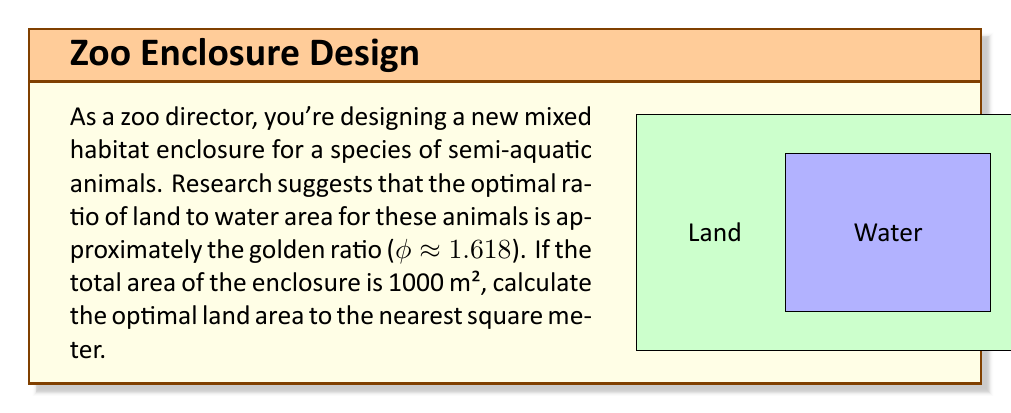Can you solve this math problem? Let's approach this step-by-step:

1) We know that the total area is 1000 m² and the ratio of land to water should be φ:1.

2) Let x be the land area. Then (1000 - x) is the water area.

3) We can set up the equation:

   $$\frac{x}{1000-x} = φ$$

4) Solve for x:
   $$x = φ(1000-x)$$
   $$x = 1000φ - φx$$
   $$x + φx = 1000φ$$
   $$x(1 + φ) = 1000φ$$
   $$x = \frac{1000φ}{1 + φ}$$

5) We know that φ ≈ 1.618. Let's substitute this:
   $$x = \frac{1000 * 1.618}{1 + 1.618} = \frac{1618}{2.618} ≈ 618.03$$

6) Rounding to the nearest square meter:
   x ≈ 618 m²

Therefore, the optimal land area is approximately 618 m².
Answer: 618 m² 